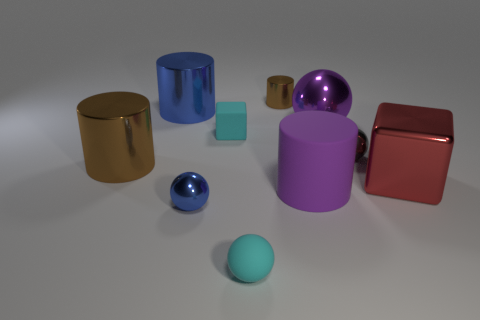Subtract 1 balls. How many balls are left? 3 Subtract all spheres. How many objects are left? 6 Subtract 0 gray cylinders. How many objects are left? 10 Subtract all tiny balls. Subtract all tiny objects. How many objects are left? 2 Add 9 tiny gray metal spheres. How many tiny gray metal spheres are left? 10 Add 5 cyan cylinders. How many cyan cylinders exist? 5 